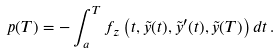<formula> <loc_0><loc_0><loc_500><loc_500>p ( T ) = - \int _ { a } ^ { T } f _ { z } \left ( t , \tilde { y } ( t ) , \tilde { y } ^ { \prime } ( t ) , \tilde { y } ( T ) \right ) d t \, .</formula> 